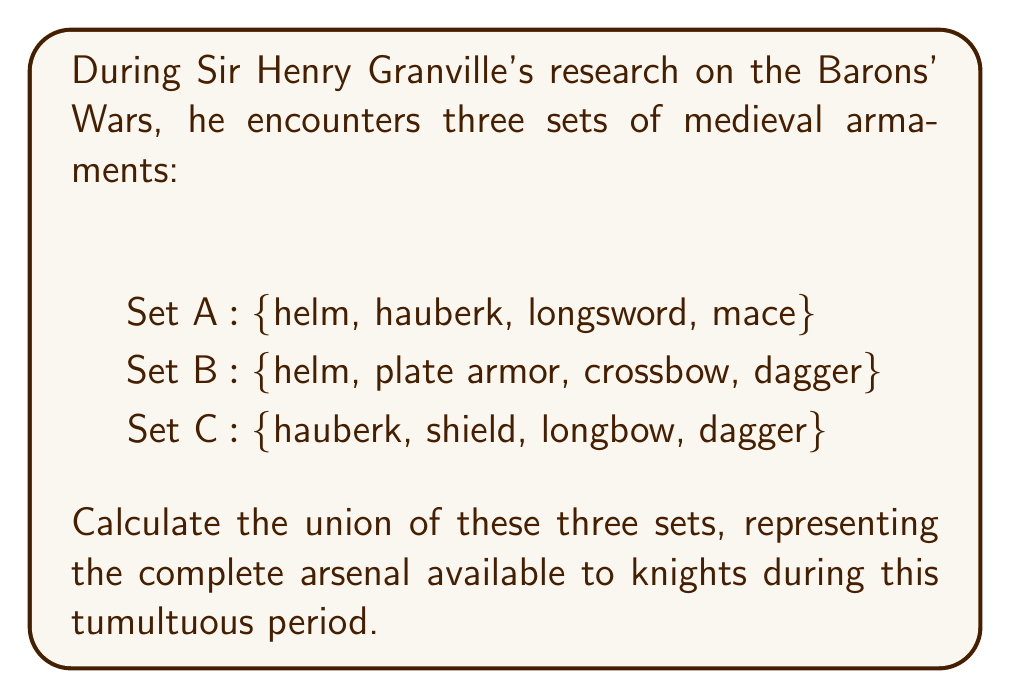Teach me how to tackle this problem. To find the union of sets A, B, and C, we need to combine all unique elements from each set. Let's approach this step-by-step:

1. Start with Set A: {helm, hauberk, longsword, mace}

2. Add unique elements from Set B:
   - helm is already included
   - Add plate armor, crossbow, and dagger
   Current union: {helm, hauberk, longsword, mace, plate armor, crossbow, dagger}

3. Add unique elements from Set C:
   - hauberk and dagger are already included
   - Add shield and longbow
   Final union: {helm, hauberk, longsword, mace, plate armor, crossbow, dagger, shield, longbow}

The union can be expressed mathematically as:

$$ A \cup B \cup C = \{x \mid x \in A \text{ or } x \in B \text{ or } x \in C\} $$

Where $\cup$ represents the union operation.
Answer: {helm, hauberk, longsword, mace, plate armor, crossbow, dagger, shield, longbow} 